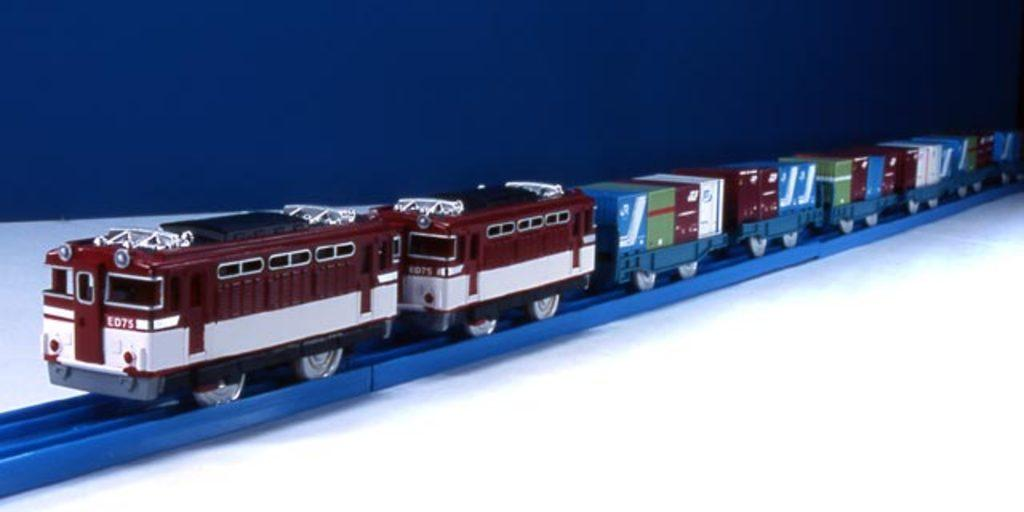What is the main subject of the image? The main subject of the image is a train. What is the color of the track on which the train is placed? The track is blue in color. What is the color of the surface on which the track is placed? The surface is white in color. What color is the background of the image? The background of the image is blue. What type of cabbage is being used as a crime deterrent in the image? There is no cabbage or crime deterrent present in the image; it features a train on a blue track. Where is the vacation destination shown in the image? There is no vacation destination shown in the image; it features a train on a blue track. 